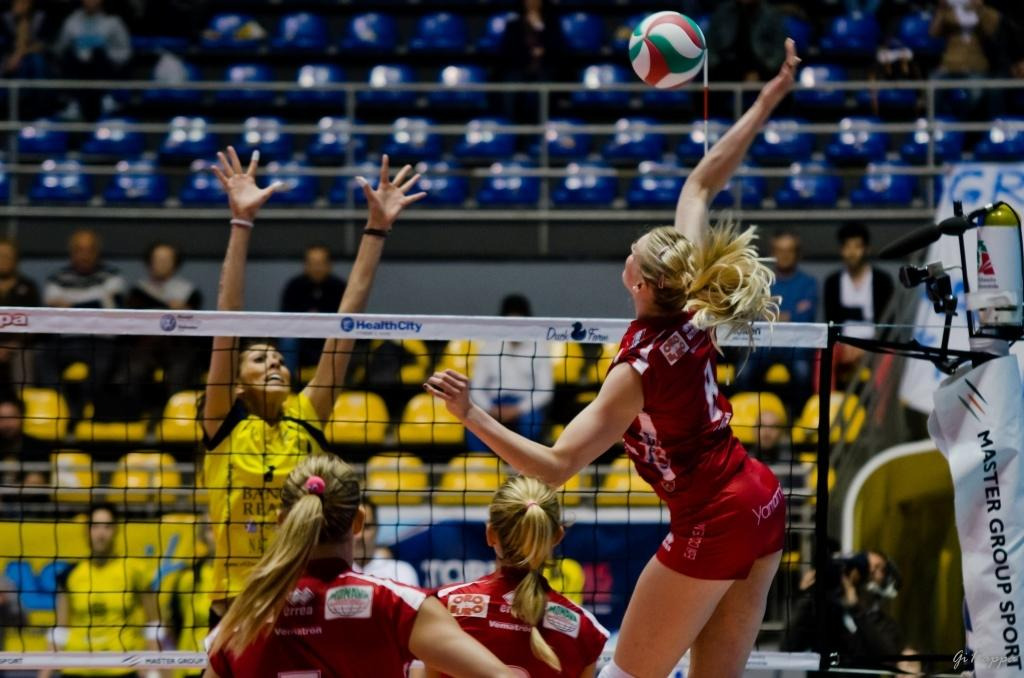How many people are in the group visible in the image? The number of people in the group cannot be determined from the provided facts. What object is present in the image besides the people? There is a ball and a net in the image. What might be the purpose of the net in the image? The net in the image might be used for catching or blocking the ball. What are the unspecified objects in the image? The nature of the unspecified objects cannot be determined from the provided facts. Can you see any clover growing on the island in the image? There is no island or clover present in the image. What type of attraction is featured in the image? There is no attraction present in the image; it features a group of people, a ball, and a net. 